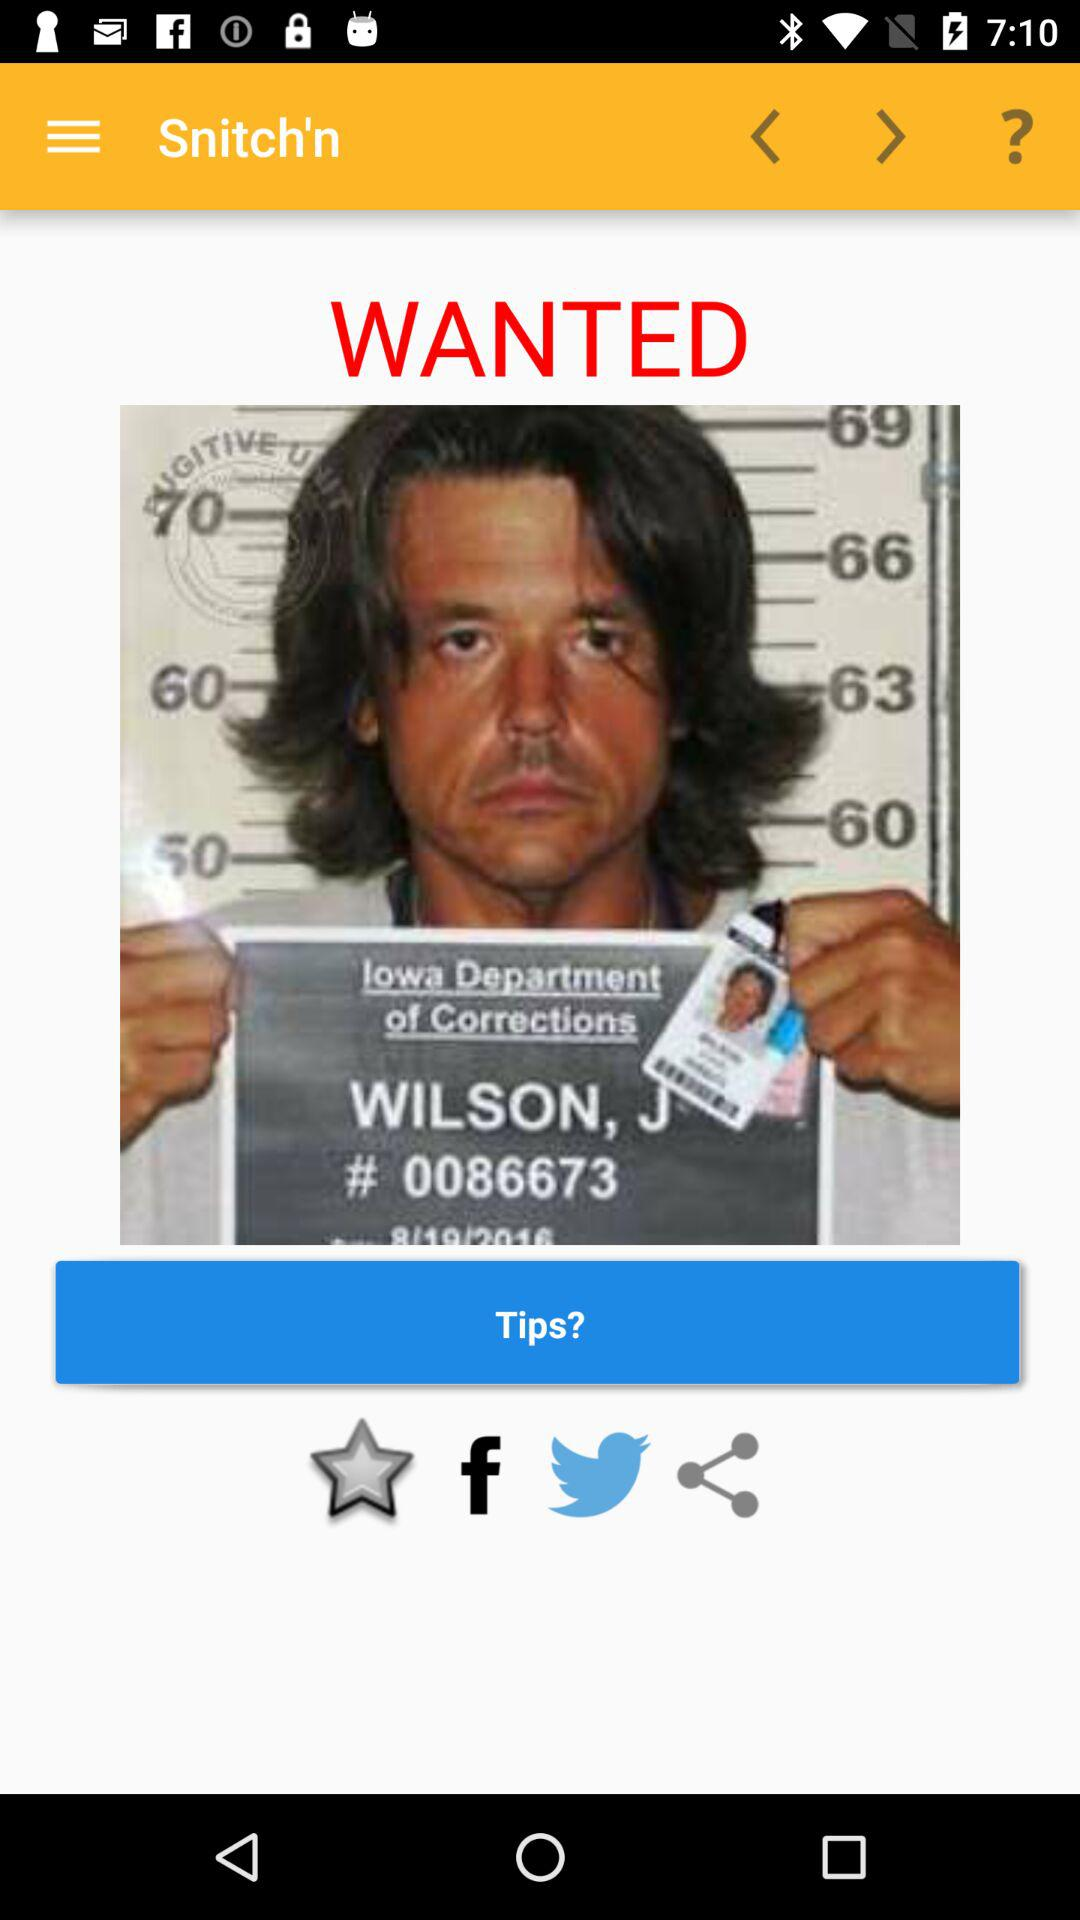What is the application name? The application name is "Snitch'n". 